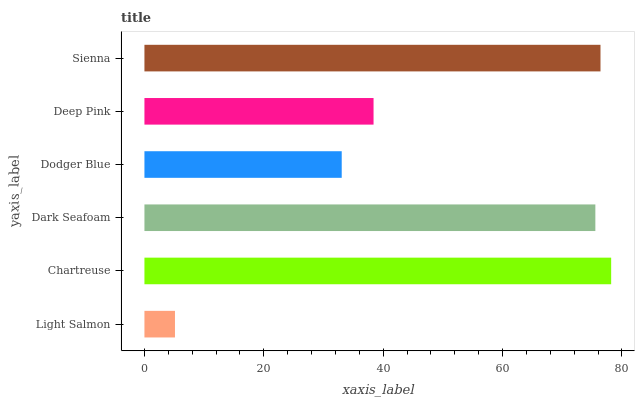Is Light Salmon the minimum?
Answer yes or no. Yes. Is Chartreuse the maximum?
Answer yes or no. Yes. Is Dark Seafoam the minimum?
Answer yes or no. No. Is Dark Seafoam the maximum?
Answer yes or no. No. Is Chartreuse greater than Dark Seafoam?
Answer yes or no. Yes. Is Dark Seafoam less than Chartreuse?
Answer yes or no. Yes. Is Dark Seafoam greater than Chartreuse?
Answer yes or no. No. Is Chartreuse less than Dark Seafoam?
Answer yes or no. No. Is Dark Seafoam the high median?
Answer yes or no. Yes. Is Deep Pink the low median?
Answer yes or no. Yes. Is Chartreuse the high median?
Answer yes or no. No. Is Dodger Blue the low median?
Answer yes or no. No. 